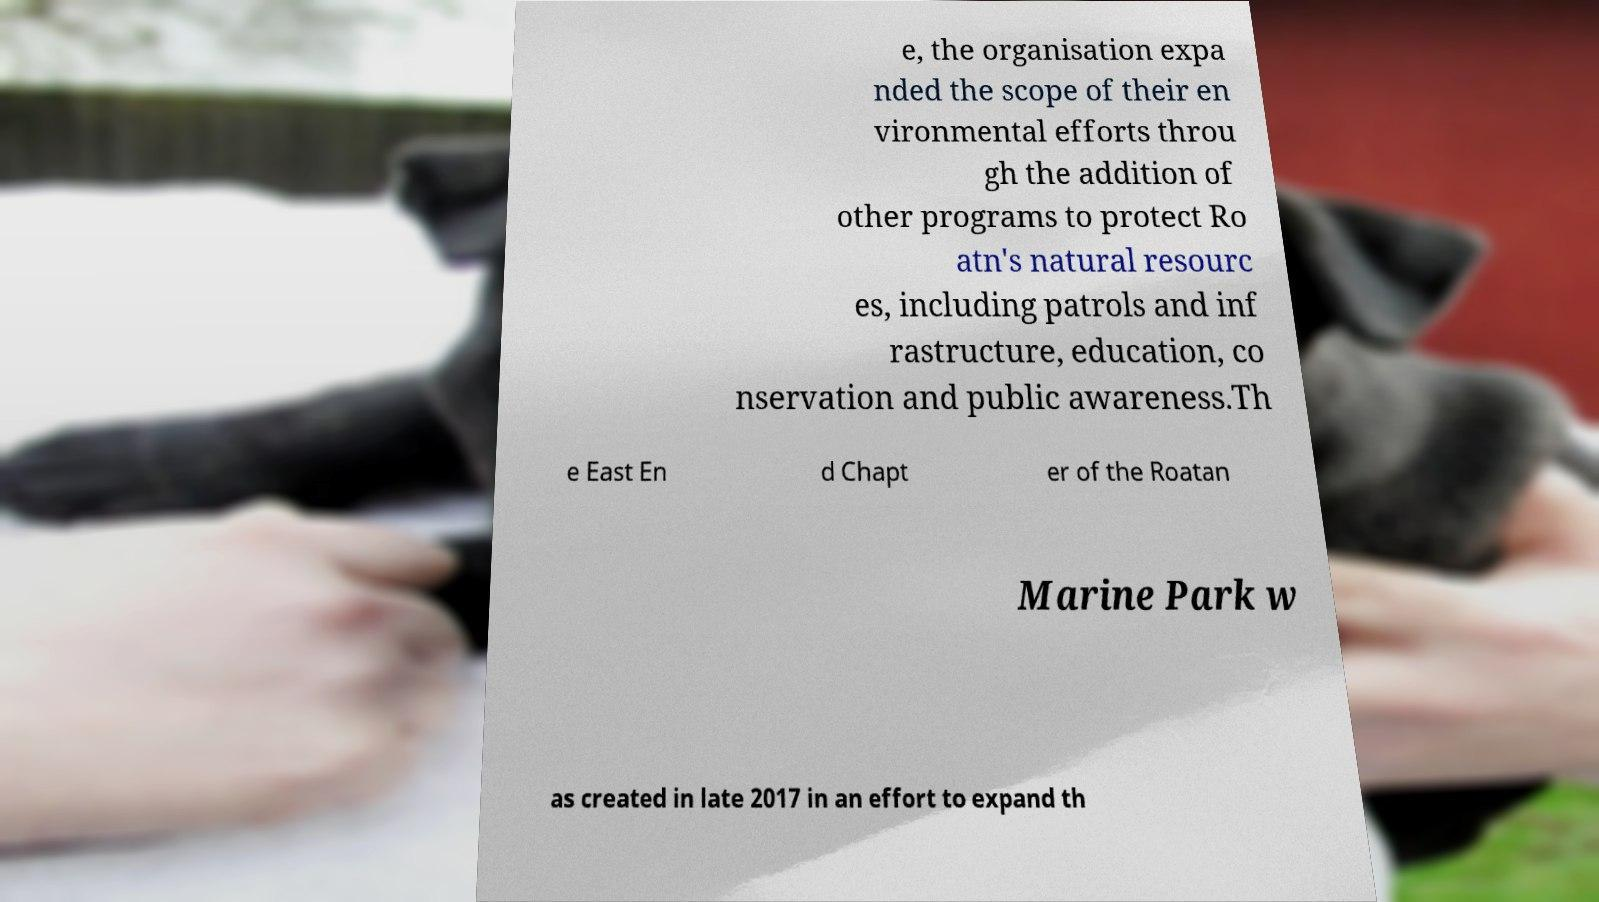Please identify and transcribe the text found in this image. e, the organisation expa nded the scope of their en vironmental efforts throu gh the addition of other programs to protect Ro atn's natural resourc es, including patrols and inf rastructure, education, co nservation and public awareness.Th e East En d Chapt er of the Roatan Marine Park w as created in late 2017 in an effort to expand th 